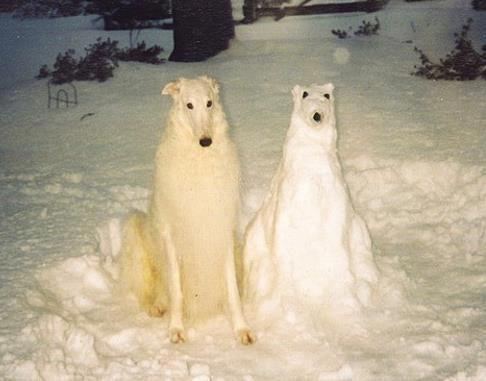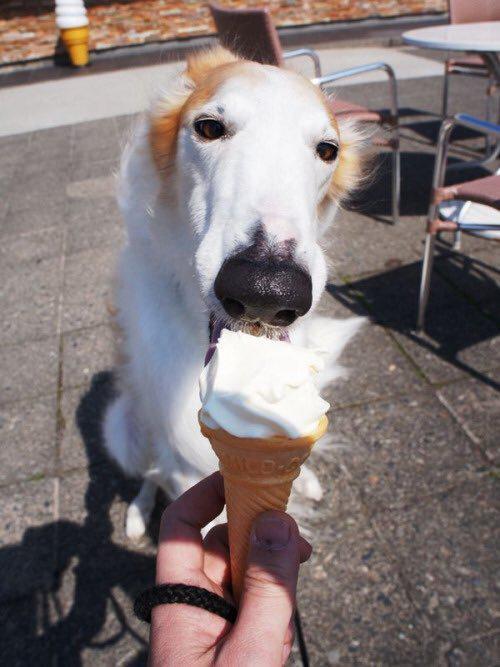The first image is the image on the left, the second image is the image on the right. For the images shown, is this caption "One image shows a dog being hand fed." true? Answer yes or no. Yes. The first image is the image on the left, the second image is the image on the right. Considering the images on both sides, is "There are two dogs with long noses eating food." valid? Answer yes or no. No. 